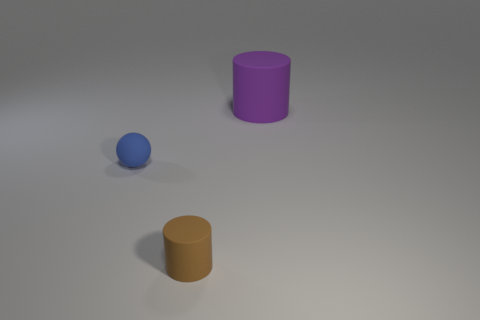Add 1 tiny gray spheres. How many objects exist? 4 Subtract all spheres. How many objects are left? 2 Subtract 1 brown cylinders. How many objects are left? 2 Subtract all tiny cubes. Subtract all cylinders. How many objects are left? 1 Add 3 rubber objects. How many rubber objects are left? 6 Add 1 large purple blocks. How many large purple blocks exist? 1 